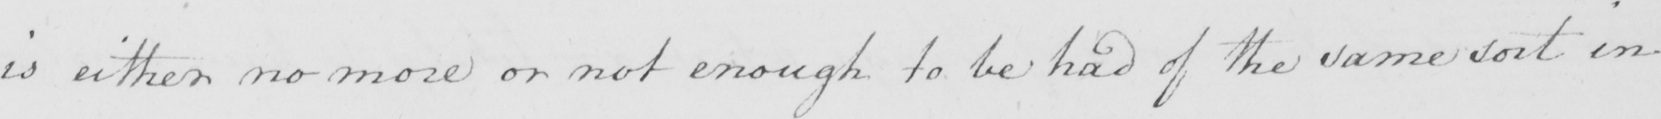Can you tell me what this handwritten text says? is either no more or not enough to be had of the same sort in 